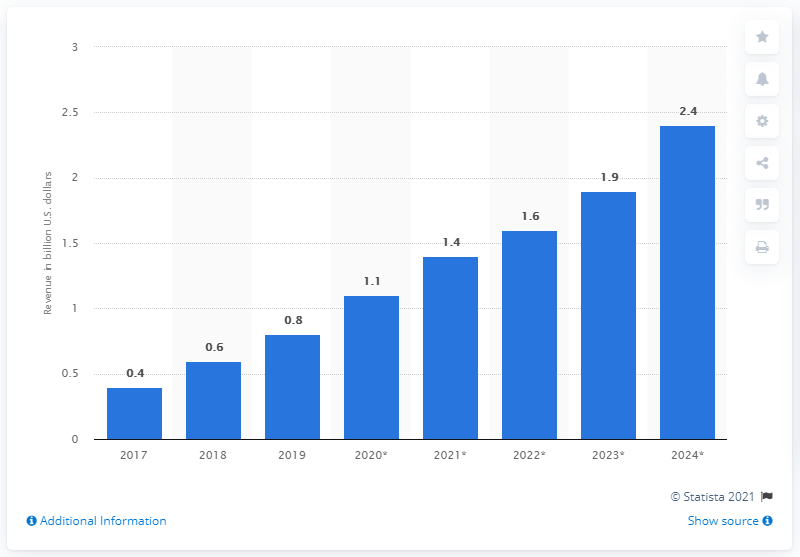Outline some significant characteristics in this image. In the United States in 2017, the revenue generated from virtual reality gaming was approximately 0.4 billion dollars. 